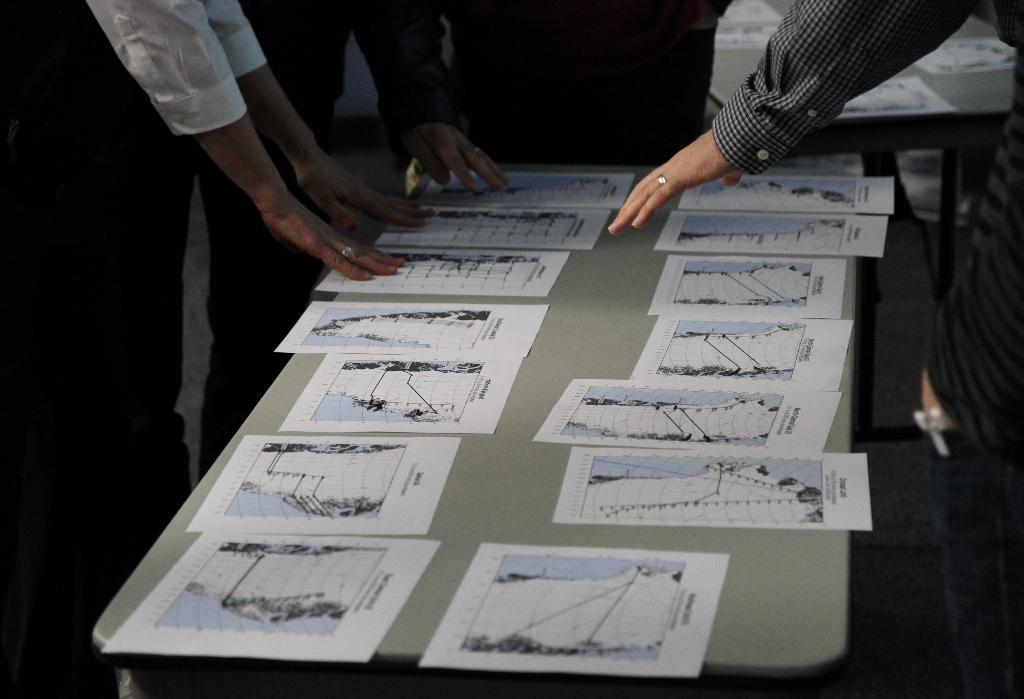What is on the table in the center of the image? There are papers on a table in the center of the image. Are there any people in the image? Yes, there are persons around the table. What can be seen in the background of the image? In the background, there is another table with papers. What type of wood is used to build the camp stove in the image? There is no camp stove present in the image; it features a table with papers and persons around it. 